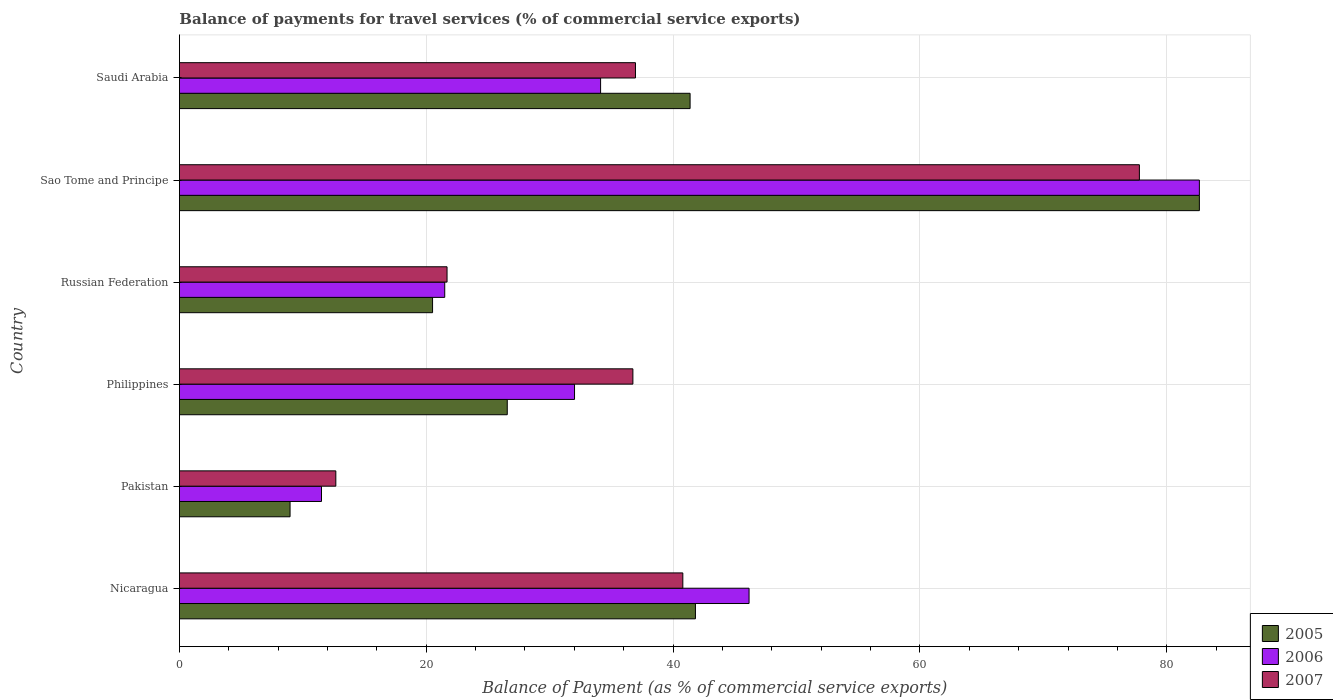How many different coloured bars are there?
Keep it short and to the point. 3. How many groups of bars are there?
Provide a succinct answer. 6. Are the number of bars on each tick of the Y-axis equal?
Provide a short and direct response. Yes. How many bars are there on the 3rd tick from the top?
Give a very brief answer. 3. How many bars are there on the 1st tick from the bottom?
Your answer should be compact. 3. What is the label of the 6th group of bars from the top?
Give a very brief answer. Nicaragua. What is the balance of payments for travel services in 2005 in Philippines?
Your answer should be very brief. 26.56. Across all countries, what is the maximum balance of payments for travel services in 2007?
Ensure brevity in your answer.  77.78. Across all countries, what is the minimum balance of payments for travel services in 2005?
Your response must be concise. 8.97. In which country was the balance of payments for travel services in 2006 maximum?
Your response must be concise. Sao Tome and Principe. What is the total balance of payments for travel services in 2006 in the graph?
Your response must be concise. 227.95. What is the difference between the balance of payments for travel services in 2006 in Philippines and that in Saudi Arabia?
Give a very brief answer. -2.11. What is the difference between the balance of payments for travel services in 2006 in Saudi Arabia and the balance of payments for travel services in 2007 in Russian Federation?
Give a very brief answer. 12.44. What is the average balance of payments for travel services in 2006 per country?
Give a very brief answer. 37.99. What is the difference between the balance of payments for travel services in 2007 and balance of payments for travel services in 2006 in Sao Tome and Principe?
Make the answer very short. -4.86. What is the ratio of the balance of payments for travel services in 2006 in Russian Federation to that in Sao Tome and Principe?
Ensure brevity in your answer.  0.26. Is the difference between the balance of payments for travel services in 2007 in Nicaragua and Philippines greater than the difference between the balance of payments for travel services in 2006 in Nicaragua and Philippines?
Give a very brief answer. No. What is the difference between the highest and the second highest balance of payments for travel services in 2007?
Your response must be concise. 36.99. What is the difference between the highest and the lowest balance of payments for travel services in 2005?
Ensure brevity in your answer.  73.68. Is the sum of the balance of payments for travel services in 2007 in Pakistan and Russian Federation greater than the maximum balance of payments for travel services in 2005 across all countries?
Your answer should be compact. No. Is it the case that in every country, the sum of the balance of payments for travel services in 2006 and balance of payments for travel services in 2007 is greater than the balance of payments for travel services in 2005?
Your answer should be very brief. Yes. Are all the bars in the graph horizontal?
Provide a succinct answer. Yes. Where does the legend appear in the graph?
Your response must be concise. Bottom right. How many legend labels are there?
Make the answer very short. 3. How are the legend labels stacked?
Ensure brevity in your answer.  Vertical. What is the title of the graph?
Ensure brevity in your answer.  Balance of payments for travel services (% of commercial service exports). What is the label or title of the X-axis?
Ensure brevity in your answer.  Balance of Payment (as % of commercial service exports). What is the label or title of the Y-axis?
Offer a very short reply. Country. What is the Balance of Payment (as % of commercial service exports) of 2005 in Nicaragua?
Keep it short and to the point. 41.81. What is the Balance of Payment (as % of commercial service exports) in 2006 in Nicaragua?
Offer a very short reply. 46.16. What is the Balance of Payment (as % of commercial service exports) in 2007 in Nicaragua?
Your answer should be compact. 40.79. What is the Balance of Payment (as % of commercial service exports) in 2005 in Pakistan?
Keep it short and to the point. 8.97. What is the Balance of Payment (as % of commercial service exports) in 2006 in Pakistan?
Provide a short and direct response. 11.51. What is the Balance of Payment (as % of commercial service exports) of 2007 in Pakistan?
Offer a very short reply. 12.67. What is the Balance of Payment (as % of commercial service exports) in 2005 in Philippines?
Your response must be concise. 26.56. What is the Balance of Payment (as % of commercial service exports) in 2006 in Philippines?
Your response must be concise. 32.02. What is the Balance of Payment (as % of commercial service exports) of 2007 in Philippines?
Your answer should be very brief. 36.74. What is the Balance of Payment (as % of commercial service exports) in 2005 in Russian Federation?
Offer a very short reply. 20.51. What is the Balance of Payment (as % of commercial service exports) in 2006 in Russian Federation?
Give a very brief answer. 21.5. What is the Balance of Payment (as % of commercial service exports) in 2007 in Russian Federation?
Your answer should be compact. 21.69. What is the Balance of Payment (as % of commercial service exports) in 2005 in Sao Tome and Principe?
Make the answer very short. 82.64. What is the Balance of Payment (as % of commercial service exports) in 2006 in Sao Tome and Principe?
Give a very brief answer. 82.64. What is the Balance of Payment (as % of commercial service exports) in 2007 in Sao Tome and Principe?
Offer a terse response. 77.78. What is the Balance of Payment (as % of commercial service exports) of 2005 in Saudi Arabia?
Provide a succinct answer. 41.38. What is the Balance of Payment (as % of commercial service exports) of 2006 in Saudi Arabia?
Your response must be concise. 34.13. What is the Balance of Payment (as % of commercial service exports) of 2007 in Saudi Arabia?
Provide a short and direct response. 36.95. Across all countries, what is the maximum Balance of Payment (as % of commercial service exports) of 2005?
Make the answer very short. 82.64. Across all countries, what is the maximum Balance of Payment (as % of commercial service exports) in 2006?
Ensure brevity in your answer.  82.64. Across all countries, what is the maximum Balance of Payment (as % of commercial service exports) in 2007?
Ensure brevity in your answer.  77.78. Across all countries, what is the minimum Balance of Payment (as % of commercial service exports) in 2005?
Give a very brief answer. 8.97. Across all countries, what is the minimum Balance of Payment (as % of commercial service exports) of 2006?
Provide a short and direct response. 11.51. Across all countries, what is the minimum Balance of Payment (as % of commercial service exports) in 2007?
Offer a very short reply. 12.67. What is the total Balance of Payment (as % of commercial service exports) in 2005 in the graph?
Offer a very short reply. 221.87. What is the total Balance of Payment (as % of commercial service exports) in 2006 in the graph?
Offer a terse response. 227.95. What is the total Balance of Payment (as % of commercial service exports) in 2007 in the graph?
Your answer should be very brief. 226.63. What is the difference between the Balance of Payment (as % of commercial service exports) of 2005 in Nicaragua and that in Pakistan?
Offer a terse response. 32.85. What is the difference between the Balance of Payment (as % of commercial service exports) of 2006 in Nicaragua and that in Pakistan?
Give a very brief answer. 34.64. What is the difference between the Balance of Payment (as % of commercial service exports) of 2007 in Nicaragua and that in Pakistan?
Offer a terse response. 28.12. What is the difference between the Balance of Payment (as % of commercial service exports) of 2005 in Nicaragua and that in Philippines?
Provide a short and direct response. 15.25. What is the difference between the Balance of Payment (as % of commercial service exports) in 2006 in Nicaragua and that in Philippines?
Your response must be concise. 14.14. What is the difference between the Balance of Payment (as % of commercial service exports) in 2007 in Nicaragua and that in Philippines?
Ensure brevity in your answer.  4.05. What is the difference between the Balance of Payment (as % of commercial service exports) in 2005 in Nicaragua and that in Russian Federation?
Your answer should be compact. 21.3. What is the difference between the Balance of Payment (as % of commercial service exports) of 2006 in Nicaragua and that in Russian Federation?
Offer a terse response. 24.66. What is the difference between the Balance of Payment (as % of commercial service exports) of 2007 in Nicaragua and that in Russian Federation?
Give a very brief answer. 19.1. What is the difference between the Balance of Payment (as % of commercial service exports) of 2005 in Nicaragua and that in Sao Tome and Principe?
Your answer should be very brief. -40.83. What is the difference between the Balance of Payment (as % of commercial service exports) in 2006 in Nicaragua and that in Sao Tome and Principe?
Your answer should be very brief. -36.49. What is the difference between the Balance of Payment (as % of commercial service exports) of 2007 in Nicaragua and that in Sao Tome and Principe?
Your answer should be compact. -36.99. What is the difference between the Balance of Payment (as % of commercial service exports) in 2005 in Nicaragua and that in Saudi Arabia?
Provide a succinct answer. 0.43. What is the difference between the Balance of Payment (as % of commercial service exports) of 2006 in Nicaragua and that in Saudi Arabia?
Provide a succinct answer. 12.03. What is the difference between the Balance of Payment (as % of commercial service exports) in 2007 in Nicaragua and that in Saudi Arabia?
Offer a terse response. 3.84. What is the difference between the Balance of Payment (as % of commercial service exports) of 2005 in Pakistan and that in Philippines?
Ensure brevity in your answer.  -17.6. What is the difference between the Balance of Payment (as % of commercial service exports) in 2006 in Pakistan and that in Philippines?
Give a very brief answer. -20.5. What is the difference between the Balance of Payment (as % of commercial service exports) in 2007 in Pakistan and that in Philippines?
Your answer should be compact. -24.07. What is the difference between the Balance of Payment (as % of commercial service exports) in 2005 in Pakistan and that in Russian Federation?
Your answer should be compact. -11.55. What is the difference between the Balance of Payment (as % of commercial service exports) of 2006 in Pakistan and that in Russian Federation?
Offer a very short reply. -9.98. What is the difference between the Balance of Payment (as % of commercial service exports) in 2007 in Pakistan and that in Russian Federation?
Your answer should be very brief. -9.01. What is the difference between the Balance of Payment (as % of commercial service exports) in 2005 in Pakistan and that in Sao Tome and Principe?
Your answer should be very brief. -73.68. What is the difference between the Balance of Payment (as % of commercial service exports) in 2006 in Pakistan and that in Sao Tome and Principe?
Your answer should be very brief. -71.13. What is the difference between the Balance of Payment (as % of commercial service exports) in 2007 in Pakistan and that in Sao Tome and Principe?
Your answer should be compact. -65.11. What is the difference between the Balance of Payment (as % of commercial service exports) in 2005 in Pakistan and that in Saudi Arabia?
Offer a very short reply. -32.41. What is the difference between the Balance of Payment (as % of commercial service exports) in 2006 in Pakistan and that in Saudi Arabia?
Provide a short and direct response. -22.61. What is the difference between the Balance of Payment (as % of commercial service exports) of 2007 in Pakistan and that in Saudi Arabia?
Your response must be concise. -24.28. What is the difference between the Balance of Payment (as % of commercial service exports) in 2005 in Philippines and that in Russian Federation?
Offer a very short reply. 6.05. What is the difference between the Balance of Payment (as % of commercial service exports) in 2006 in Philippines and that in Russian Federation?
Offer a terse response. 10.52. What is the difference between the Balance of Payment (as % of commercial service exports) of 2007 in Philippines and that in Russian Federation?
Your response must be concise. 15.06. What is the difference between the Balance of Payment (as % of commercial service exports) of 2005 in Philippines and that in Sao Tome and Principe?
Keep it short and to the point. -56.08. What is the difference between the Balance of Payment (as % of commercial service exports) in 2006 in Philippines and that in Sao Tome and Principe?
Provide a short and direct response. -50.63. What is the difference between the Balance of Payment (as % of commercial service exports) in 2007 in Philippines and that in Sao Tome and Principe?
Your answer should be compact. -41.04. What is the difference between the Balance of Payment (as % of commercial service exports) of 2005 in Philippines and that in Saudi Arabia?
Your response must be concise. -14.81. What is the difference between the Balance of Payment (as % of commercial service exports) of 2006 in Philippines and that in Saudi Arabia?
Provide a short and direct response. -2.11. What is the difference between the Balance of Payment (as % of commercial service exports) in 2007 in Philippines and that in Saudi Arabia?
Keep it short and to the point. -0.21. What is the difference between the Balance of Payment (as % of commercial service exports) of 2005 in Russian Federation and that in Sao Tome and Principe?
Provide a succinct answer. -62.13. What is the difference between the Balance of Payment (as % of commercial service exports) in 2006 in Russian Federation and that in Sao Tome and Principe?
Offer a terse response. -61.15. What is the difference between the Balance of Payment (as % of commercial service exports) of 2007 in Russian Federation and that in Sao Tome and Principe?
Ensure brevity in your answer.  -56.1. What is the difference between the Balance of Payment (as % of commercial service exports) in 2005 in Russian Federation and that in Saudi Arabia?
Your answer should be very brief. -20.87. What is the difference between the Balance of Payment (as % of commercial service exports) of 2006 in Russian Federation and that in Saudi Arabia?
Provide a short and direct response. -12.63. What is the difference between the Balance of Payment (as % of commercial service exports) of 2007 in Russian Federation and that in Saudi Arabia?
Keep it short and to the point. -15.27. What is the difference between the Balance of Payment (as % of commercial service exports) in 2005 in Sao Tome and Principe and that in Saudi Arabia?
Your answer should be very brief. 41.26. What is the difference between the Balance of Payment (as % of commercial service exports) of 2006 in Sao Tome and Principe and that in Saudi Arabia?
Give a very brief answer. 48.52. What is the difference between the Balance of Payment (as % of commercial service exports) of 2007 in Sao Tome and Principe and that in Saudi Arabia?
Your answer should be very brief. 40.83. What is the difference between the Balance of Payment (as % of commercial service exports) in 2005 in Nicaragua and the Balance of Payment (as % of commercial service exports) in 2006 in Pakistan?
Offer a terse response. 30.3. What is the difference between the Balance of Payment (as % of commercial service exports) of 2005 in Nicaragua and the Balance of Payment (as % of commercial service exports) of 2007 in Pakistan?
Keep it short and to the point. 29.14. What is the difference between the Balance of Payment (as % of commercial service exports) of 2006 in Nicaragua and the Balance of Payment (as % of commercial service exports) of 2007 in Pakistan?
Ensure brevity in your answer.  33.48. What is the difference between the Balance of Payment (as % of commercial service exports) of 2005 in Nicaragua and the Balance of Payment (as % of commercial service exports) of 2006 in Philippines?
Your answer should be very brief. 9.8. What is the difference between the Balance of Payment (as % of commercial service exports) of 2005 in Nicaragua and the Balance of Payment (as % of commercial service exports) of 2007 in Philippines?
Make the answer very short. 5.07. What is the difference between the Balance of Payment (as % of commercial service exports) of 2006 in Nicaragua and the Balance of Payment (as % of commercial service exports) of 2007 in Philippines?
Make the answer very short. 9.41. What is the difference between the Balance of Payment (as % of commercial service exports) of 2005 in Nicaragua and the Balance of Payment (as % of commercial service exports) of 2006 in Russian Federation?
Provide a short and direct response. 20.31. What is the difference between the Balance of Payment (as % of commercial service exports) in 2005 in Nicaragua and the Balance of Payment (as % of commercial service exports) in 2007 in Russian Federation?
Your answer should be compact. 20.13. What is the difference between the Balance of Payment (as % of commercial service exports) in 2006 in Nicaragua and the Balance of Payment (as % of commercial service exports) in 2007 in Russian Federation?
Your answer should be very brief. 24.47. What is the difference between the Balance of Payment (as % of commercial service exports) in 2005 in Nicaragua and the Balance of Payment (as % of commercial service exports) in 2006 in Sao Tome and Principe?
Your response must be concise. -40.83. What is the difference between the Balance of Payment (as % of commercial service exports) in 2005 in Nicaragua and the Balance of Payment (as % of commercial service exports) in 2007 in Sao Tome and Principe?
Give a very brief answer. -35.97. What is the difference between the Balance of Payment (as % of commercial service exports) in 2006 in Nicaragua and the Balance of Payment (as % of commercial service exports) in 2007 in Sao Tome and Principe?
Ensure brevity in your answer.  -31.63. What is the difference between the Balance of Payment (as % of commercial service exports) in 2005 in Nicaragua and the Balance of Payment (as % of commercial service exports) in 2006 in Saudi Arabia?
Offer a terse response. 7.68. What is the difference between the Balance of Payment (as % of commercial service exports) of 2005 in Nicaragua and the Balance of Payment (as % of commercial service exports) of 2007 in Saudi Arabia?
Offer a very short reply. 4.86. What is the difference between the Balance of Payment (as % of commercial service exports) in 2006 in Nicaragua and the Balance of Payment (as % of commercial service exports) in 2007 in Saudi Arabia?
Offer a terse response. 9.21. What is the difference between the Balance of Payment (as % of commercial service exports) in 2005 in Pakistan and the Balance of Payment (as % of commercial service exports) in 2006 in Philippines?
Ensure brevity in your answer.  -23.05. What is the difference between the Balance of Payment (as % of commercial service exports) of 2005 in Pakistan and the Balance of Payment (as % of commercial service exports) of 2007 in Philippines?
Your response must be concise. -27.78. What is the difference between the Balance of Payment (as % of commercial service exports) in 2006 in Pakistan and the Balance of Payment (as % of commercial service exports) in 2007 in Philippines?
Offer a very short reply. -25.23. What is the difference between the Balance of Payment (as % of commercial service exports) in 2005 in Pakistan and the Balance of Payment (as % of commercial service exports) in 2006 in Russian Federation?
Your answer should be compact. -12.53. What is the difference between the Balance of Payment (as % of commercial service exports) of 2005 in Pakistan and the Balance of Payment (as % of commercial service exports) of 2007 in Russian Federation?
Your answer should be compact. -12.72. What is the difference between the Balance of Payment (as % of commercial service exports) in 2006 in Pakistan and the Balance of Payment (as % of commercial service exports) in 2007 in Russian Federation?
Make the answer very short. -10.17. What is the difference between the Balance of Payment (as % of commercial service exports) of 2005 in Pakistan and the Balance of Payment (as % of commercial service exports) of 2006 in Sao Tome and Principe?
Your response must be concise. -73.68. What is the difference between the Balance of Payment (as % of commercial service exports) in 2005 in Pakistan and the Balance of Payment (as % of commercial service exports) in 2007 in Sao Tome and Principe?
Your response must be concise. -68.82. What is the difference between the Balance of Payment (as % of commercial service exports) of 2006 in Pakistan and the Balance of Payment (as % of commercial service exports) of 2007 in Sao Tome and Principe?
Your answer should be very brief. -66.27. What is the difference between the Balance of Payment (as % of commercial service exports) of 2005 in Pakistan and the Balance of Payment (as % of commercial service exports) of 2006 in Saudi Arabia?
Your response must be concise. -25.16. What is the difference between the Balance of Payment (as % of commercial service exports) of 2005 in Pakistan and the Balance of Payment (as % of commercial service exports) of 2007 in Saudi Arabia?
Give a very brief answer. -27.99. What is the difference between the Balance of Payment (as % of commercial service exports) of 2006 in Pakistan and the Balance of Payment (as % of commercial service exports) of 2007 in Saudi Arabia?
Provide a succinct answer. -25.44. What is the difference between the Balance of Payment (as % of commercial service exports) in 2005 in Philippines and the Balance of Payment (as % of commercial service exports) in 2006 in Russian Federation?
Offer a terse response. 5.07. What is the difference between the Balance of Payment (as % of commercial service exports) in 2005 in Philippines and the Balance of Payment (as % of commercial service exports) in 2007 in Russian Federation?
Your answer should be compact. 4.88. What is the difference between the Balance of Payment (as % of commercial service exports) of 2006 in Philippines and the Balance of Payment (as % of commercial service exports) of 2007 in Russian Federation?
Make the answer very short. 10.33. What is the difference between the Balance of Payment (as % of commercial service exports) of 2005 in Philippines and the Balance of Payment (as % of commercial service exports) of 2006 in Sao Tome and Principe?
Your response must be concise. -56.08. What is the difference between the Balance of Payment (as % of commercial service exports) of 2005 in Philippines and the Balance of Payment (as % of commercial service exports) of 2007 in Sao Tome and Principe?
Offer a terse response. -51.22. What is the difference between the Balance of Payment (as % of commercial service exports) of 2006 in Philippines and the Balance of Payment (as % of commercial service exports) of 2007 in Sao Tome and Principe?
Ensure brevity in your answer.  -45.77. What is the difference between the Balance of Payment (as % of commercial service exports) in 2005 in Philippines and the Balance of Payment (as % of commercial service exports) in 2006 in Saudi Arabia?
Ensure brevity in your answer.  -7.56. What is the difference between the Balance of Payment (as % of commercial service exports) in 2005 in Philippines and the Balance of Payment (as % of commercial service exports) in 2007 in Saudi Arabia?
Your response must be concise. -10.39. What is the difference between the Balance of Payment (as % of commercial service exports) in 2006 in Philippines and the Balance of Payment (as % of commercial service exports) in 2007 in Saudi Arabia?
Provide a short and direct response. -4.94. What is the difference between the Balance of Payment (as % of commercial service exports) of 2005 in Russian Federation and the Balance of Payment (as % of commercial service exports) of 2006 in Sao Tome and Principe?
Make the answer very short. -62.13. What is the difference between the Balance of Payment (as % of commercial service exports) of 2005 in Russian Federation and the Balance of Payment (as % of commercial service exports) of 2007 in Sao Tome and Principe?
Your response must be concise. -57.27. What is the difference between the Balance of Payment (as % of commercial service exports) in 2006 in Russian Federation and the Balance of Payment (as % of commercial service exports) in 2007 in Sao Tome and Principe?
Provide a short and direct response. -56.29. What is the difference between the Balance of Payment (as % of commercial service exports) of 2005 in Russian Federation and the Balance of Payment (as % of commercial service exports) of 2006 in Saudi Arabia?
Your answer should be compact. -13.61. What is the difference between the Balance of Payment (as % of commercial service exports) in 2005 in Russian Federation and the Balance of Payment (as % of commercial service exports) in 2007 in Saudi Arabia?
Your response must be concise. -16.44. What is the difference between the Balance of Payment (as % of commercial service exports) of 2006 in Russian Federation and the Balance of Payment (as % of commercial service exports) of 2007 in Saudi Arabia?
Offer a terse response. -15.45. What is the difference between the Balance of Payment (as % of commercial service exports) of 2005 in Sao Tome and Principe and the Balance of Payment (as % of commercial service exports) of 2006 in Saudi Arabia?
Your answer should be compact. 48.52. What is the difference between the Balance of Payment (as % of commercial service exports) of 2005 in Sao Tome and Principe and the Balance of Payment (as % of commercial service exports) of 2007 in Saudi Arabia?
Give a very brief answer. 45.69. What is the difference between the Balance of Payment (as % of commercial service exports) in 2006 in Sao Tome and Principe and the Balance of Payment (as % of commercial service exports) in 2007 in Saudi Arabia?
Your answer should be very brief. 45.69. What is the average Balance of Payment (as % of commercial service exports) in 2005 per country?
Keep it short and to the point. 36.98. What is the average Balance of Payment (as % of commercial service exports) in 2006 per country?
Offer a terse response. 37.99. What is the average Balance of Payment (as % of commercial service exports) in 2007 per country?
Offer a terse response. 37.77. What is the difference between the Balance of Payment (as % of commercial service exports) in 2005 and Balance of Payment (as % of commercial service exports) in 2006 in Nicaragua?
Provide a short and direct response. -4.34. What is the difference between the Balance of Payment (as % of commercial service exports) of 2006 and Balance of Payment (as % of commercial service exports) of 2007 in Nicaragua?
Offer a very short reply. 5.37. What is the difference between the Balance of Payment (as % of commercial service exports) of 2005 and Balance of Payment (as % of commercial service exports) of 2006 in Pakistan?
Provide a succinct answer. -2.55. What is the difference between the Balance of Payment (as % of commercial service exports) of 2005 and Balance of Payment (as % of commercial service exports) of 2007 in Pakistan?
Your answer should be compact. -3.71. What is the difference between the Balance of Payment (as % of commercial service exports) of 2006 and Balance of Payment (as % of commercial service exports) of 2007 in Pakistan?
Provide a short and direct response. -1.16. What is the difference between the Balance of Payment (as % of commercial service exports) in 2005 and Balance of Payment (as % of commercial service exports) in 2006 in Philippines?
Give a very brief answer. -5.45. What is the difference between the Balance of Payment (as % of commercial service exports) in 2005 and Balance of Payment (as % of commercial service exports) in 2007 in Philippines?
Provide a short and direct response. -10.18. What is the difference between the Balance of Payment (as % of commercial service exports) of 2006 and Balance of Payment (as % of commercial service exports) of 2007 in Philippines?
Give a very brief answer. -4.73. What is the difference between the Balance of Payment (as % of commercial service exports) in 2005 and Balance of Payment (as % of commercial service exports) in 2006 in Russian Federation?
Make the answer very short. -0.99. What is the difference between the Balance of Payment (as % of commercial service exports) of 2005 and Balance of Payment (as % of commercial service exports) of 2007 in Russian Federation?
Make the answer very short. -1.17. What is the difference between the Balance of Payment (as % of commercial service exports) in 2006 and Balance of Payment (as % of commercial service exports) in 2007 in Russian Federation?
Provide a short and direct response. -0.19. What is the difference between the Balance of Payment (as % of commercial service exports) in 2005 and Balance of Payment (as % of commercial service exports) in 2007 in Sao Tome and Principe?
Your answer should be compact. 4.86. What is the difference between the Balance of Payment (as % of commercial service exports) in 2006 and Balance of Payment (as % of commercial service exports) in 2007 in Sao Tome and Principe?
Offer a terse response. 4.86. What is the difference between the Balance of Payment (as % of commercial service exports) of 2005 and Balance of Payment (as % of commercial service exports) of 2006 in Saudi Arabia?
Your answer should be compact. 7.25. What is the difference between the Balance of Payment (as % of commercial service exports) of 2005 and Balance of Payment (as % of commercial service exports) of 2007 in Saudi Arabia?
Keep it short and to the point. 4.43. What is the difference between the Balance of Payment (as % of commercial service exports) in 2006 and Balance of Payment (as % of commercial service exports) in 2007 in Saudi Arabia?
Make the answer very short. -2.82. What is the ratio of the Balance of Payment (as % of commercial service exports) of 2005 in Nicaragua to that in Pakistan?
Keep it short and to the point. 4.66. What is the ratio of the Balance of Payment (as % of commercial service exports) of 2006 in Nicaragua to that in Pakistan?
Offer a very short reply. 4.01. What is the ratio of the Balance of Payment (as % of commercial service exports) in 2007 in Nicaragua to that in Pakistan?
Offer a very short reply. 3.22. What is the ratio of the Balance of Payment (as % of commercial service exports) in 2005 in Nicaragua to that in Philippines?
Make the answer very short. 1.57. What is the ratio of the Balance of Payment (as % of commercial service exports) in 2006 in Nicaragua to that in Philippines?
Give a very brief answer. 1.44. What is the ratio of the Balance of Payment (as % of commercial service exports) in 2007 in Nicaragua to that in Philippines?
Provide a short and direct response. 1.11. What is the ratio of the Balance of Payment (as % of commercial service exports) in 2005 in Nicaragua to that in Russian Federation?
Give a very brief answer. 2.04. What is the ratio of the Balance of Payment (as % of commercial service exports) in 2006 in Nicaragua to that in Russian Federation?
Provide a short and direct response. 2.15. What is the ratio of the Balance of Payment (as % of commercial service exports) of 2007 in Nicaragua to that in Russian Federation?
Your answer should be compact. 1.88. What is the ratio of the Balance of Payment (as % of commercial service exports) in 2005 in Nicaragua to that in Sao Tome and Principe?
Ensure brevity in your answer.  0.51. What is the ratio of the Balance of Payment (as % of commercial service exports) in 2006 in Nicaragua to that in Sao Tome and Principe?
Your answer should be compact. 0.56. What is the ratio of the Balance of Payment (as % of commercial service exports) in 2007 in Nicaragua to that in Sao Tome and Principe?
Offer a very short reply. 0.52. What is the ratio of the Balance of Payment (as % of commercial service exports) in 2005 in Nicaragua to that in Saudi Arabia?
Provide a short and direct response. 1.01. What is the ratio of the Balance of Payment (as % of commercial service exports) of 2006 in Nicaragua to that in Saudi Arabia?
Provide a short and direct response. 1.35. What is the ratio of the Balance of Payment (as % of commercial service exports) in 2007 in Nicaragua to that in Saudi Arabia?
Provide a succinct answer. 1.1. What is the ratio of the Balance of Payment (as % of commercial service exports) in 2005 in Pakistan to that in Philippines?
Your response must be concise. 0.34. What is the ratio of the Balance of Payment (as % of commercial service exports) in 2006 in Pakistan to that in Philippines?
Provide a short and direct response. 0.36. What is the ratio of the Balance of Payment (as % of commercial service exports) of 2007 in Pakistan to that in Philippines?
Give a very brief answer. 0.34. What is the ratio of the Balance of Payment (as % of commercial service exports) in 2005 in Pakistan to that in Russian Federation?
Your answer should be very brief. 0.44. What is the ratio of the Balance of Payment (as % of commercial service exports) in 2006 in Pakistan to that in Russian Federation?
Make the answer very short. 0.54. What is the ratio of the Balance of Payment (as % of commercial service exports) in 2007 in Pakistan to that in Russian Federation?
Make the answer very short. 0.58. What is the ratio of the Balance of Payment (as % of commercial service exports) in 2005 in Pakistan to that in Sao Tome and Principe?
Your answer should be compact. 0.11. What is the ratio of the Balance of Payment (as % of commercial service exports) in 2006 in Pakistan to that in Sao Tome and Principe?
Ensure brevity in your answer.  0.14. What is the ratio of the Balance of Payment (as % of commercial service exports) in 2007 in Pakistan to that in Sao Tome and Principe?
Give a very brief answer. 0.16. What is the ratio of the Balance of Payment (as % of commercial service exports) in 2005 in Pakistan to that in Saudi Arabia?
Provide a short and direct response. 0.22. What is the ratio of the Balance of Payment (as % of commercial service exports) in 2006 in Pakistan to that in Saudi Arabia?
Give a very brief answer. 0.34. What is the ratio of the Balance of Payment (as % of commercial service exports) of 2007 in Pakistan to that in Saudi Arabia?
Make the answer very short. 0.34. What is the ratio of the Balance of Payment (as % of commercial service exports) in 2005 in Philippines to that in Russian Federation?
Your answer should be compact. 1.3. What is the ratio of the Balance of Payment (as % of commercial service exports) of 2006 in Philippines to that in Russian Federation?
Ensure brevity in your answer.  1.49. What is the ratio of the Balance of Payment (as % of commercial service exports) in 2007 in Philippines to that in Russian Federation?
Your response must be concise. 1.69. What is the ratio of the Balance of Payment (as % of commercial service exports) of 2005 in Philippines to that in Sao Tome and Principe?
Give a very brief answer. 0.32. What is the ratio of the Balance of Payment (as % of commercial service exports) in 2006 in Philippines to that in Sao Tome and Principe?
Provide a succinct answer. 0.39. What is the ratio of the Balance of Payment (as % of commercial service exports) of 2007 in Philippines to that in Sao Tome and Principe?
Keep it short and to the point. 0.47. What is the ratio of the Balance of Payment (as % of commercial service exports) of 2005 in Philippines to that in Saudi Arabia?
Your response must be concise. 0.64. What is the ratio of the Balance of Payment (as % of commercial service exports) in 2006 in Philippines to that in Saudi Arabia?
Offer a terse response. 0.94. What is the ratio of the Balance of Payment (as % of commercial service exports) in 2005 in Russian Federation to that in Sao Tome and Principe?
Offer a terse response. 0.25. What is the ratio of the Balance of Payment (as % of commercial service exports) of 2006 in Russian Federation to that in Sao Tome and Principe?
Ensure brevity in your answer.  0.26. What is the ratio of the Balance of Payment (as % of commercial service exports) of 2007 in Russian Federation to that in Sao Tome and Principe?
Provide a short and direct response. 0.28. What is the ratio of the Balance of Payment (as % of commercial service exports) in 2005 in Russian Federation to that in Saudi Arabia?
Your answer should be compact. 0.5. What is the ratio of the Balance of Payment (as % of commercial service exports) of 2006 in Russian Federation to that in Saudi Arabia?
Provide a succinct answer. 0.63. What is the ratio of the Balance of Payment (as % of commercial service exports) of 2007 in Russian Federation to that in Saudi Arabia?
Your answer should be compact. 0.59. What is the ratio of the Balance of Payment (as % of commercial service exports) in 2005 in Sao Tome and Principe to that in Saudi Arabia?
Keep it short and to the point. 2. What is the ratio of the Balance of Payment (as % of commercial service exports) in 2006 in Sao Tome and Principe to that in Saudi Arabia?
Your answer should be very brief. 2.42. What is the ratio of the Balance of Payment (as % of commercial service exports) of 2007 in Sao Tome and Principe to that in Saudi Arabia?
Your response must be concise. 2.1. What is the difference between the highest and the second highest Balance of Payment (as % of commercial service exports) of 2005?
Offer a very short reply. 40.83. What is the difference between the highest and the second highest Balance of Payment (as % of commercial service exports) of 2006?
Your response must be concise. 36.49. What is the difference between the highest and the second highest Balance of Payment (as % of commercial service exports) in 2007?
Keep it short and to the point. 36.99. What is the difference between the highest and the lowest Balance of Payment (as % of commercial service exports) of 2005?
Provide a short and direct response. 73.68. What is the difference between the highest and the lowest Balance of Payment (as % of commercial service exports) in 2006?
Keep it short and to the point. 71.13. What is the difference between the highest and the lowest Balance of Payment (as % of commercial service exports) in 2007?
Provide a succinct answer. 65.11. 